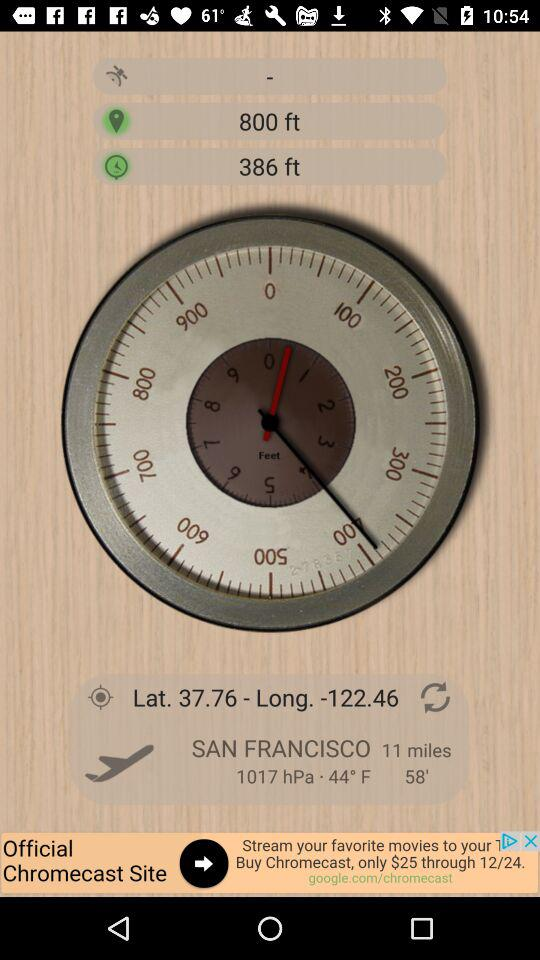What's the temperature? The temperature is 44°F. 